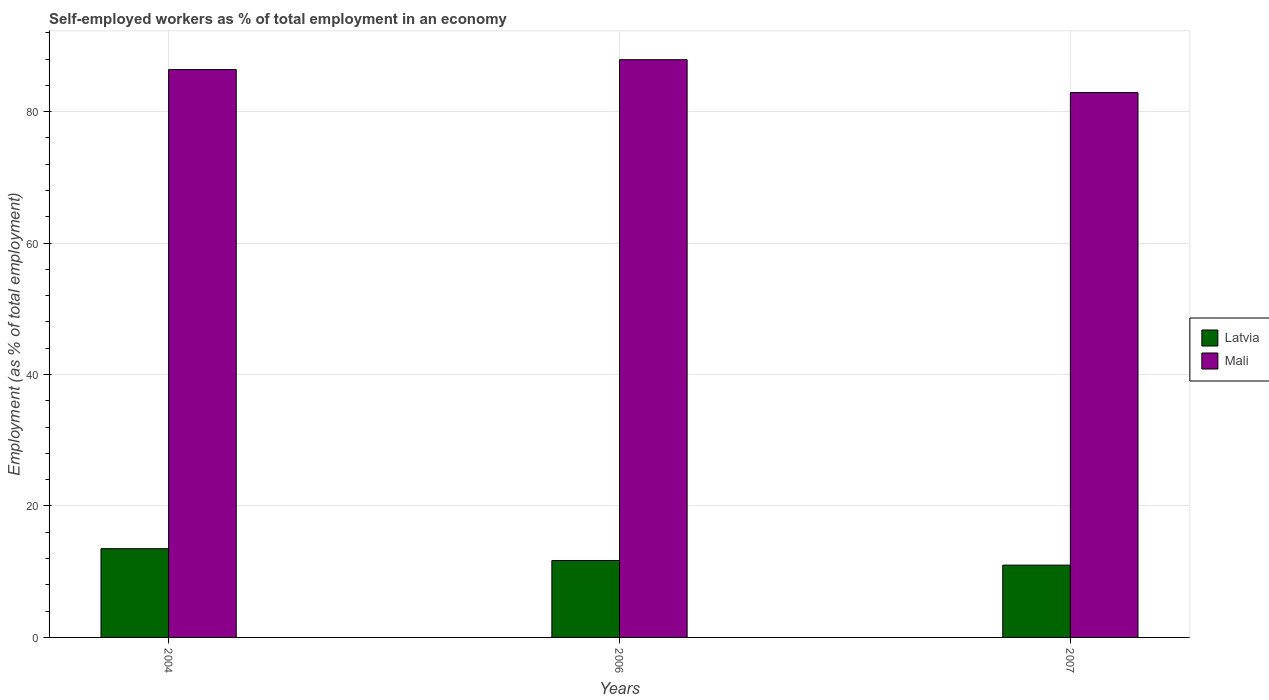How many different coloured bars are there?
Provide a succinct answer. 2. Are the number of bars per tick equal to the number of legend labels?
Your answer should be very brief. Yes. Are the number of bars on each tick of the X-axis equal?
Provide a short and direct response. Yes. How many bars are there on the 1st tick from the left?
Your answer should be very brief. 2. How many bars are there on the 1st tick from the right?
Provide a succinct answer. 2. What is the label of the 2nd group of bars from the left?
Ensure brevity in your answer.  2006. In how many cases, is the number of bars for a given year not equal to the number of legend labels?
Your response must be concise. 0. What is the percentage of self-employed workers in Latvia in 2006?
Keep it short and to the point. 11.7. Across all years, what is the maximum percentage of self-employed workers in Latvia?
Make the answer very short. 13.5. In which year was the percentage of self-employed workers in Mali minimum?
Ensure brevity in your answer.  2007. What is the total percentage of self-employed workers in Mali in the graph?
Ensure brevity in your answer.  257.2. What is the difference between the percentage of self-employed workers in Mali in 2007 and the percentage of self-employed workers in Latvia in 2006?
Provide a succinct answer. 71.2. What is the average percentage of self-employed workers in Latvia per year?
Ensure brevity in your answer.  12.07. In the year 2006, what is the difference between the percentage of self-employed workers in Latvia and percentage of self-employed workers in Mali?
Give a very brief answer. -76.2. What is the ratio of the percentage of self-employed workers in Latvia in 2004 to that in 2007?
Provide a short and direct response. 1.23. What is the difference between the highest and the second highest percentage of self-employed workers in Mali?
Your answer should be compact. 1.5. What does the 2nd bar from the left in 2004 represents?
Your answer should be compact. Mali. What does the 1st bar from the right in 2007 represents?
Offer a terse response. Mali. Are all the bars in the graph horizontal?
Provide a short and direct response. No. Does the graph contain any zero values?
Your answer should be compact. No. Where does the legend appear in the graph?
Make the answer very short. Center right. How many legend labels are there?
Ensure brevity in your answer.  2. How are the legend labels stacked?
Offer a terse response. Vertical. What is the title of the graph?
Provide a short and direct response. Self-employed workers as % of total employment in an economy. What is the label or title of the Y-axis?
Your response must be concise. Employment (as % of total employment). What is the Employment (as % of total employment) in Latvia in 2004?
Offer a terse response. 13.5. What is the Employment (as % of total employment) in Mali in 2004?
Ensure brevity in your answer.  86.4. What is the Employment (as % of total employment) of Latvia in 2006?
Keep it short and to the point. 11.7. What is the Employment (as % of total employment) of Mali in 2006?
Your answer should be very brief. 87.9. What is the Employment (as % of total employment) in Mali in 2007?
Your response must be concise. 82.9. Across all years, what is the maximum Employment (as % of total employment) of Latvia?
Your answer should be compact. 13.5. Across all years, what is the maximum Employment (as % of total employment) of Mali?
Offer a terse response. 87.9. Across all years, what is the minimum Employment (as % of total employment) of Latvia?
Your answer should be compact. 11. Across all years, what is the minimum Employment (as % of total employment) of Mali?
Your answer should be compact. 82.9. What is the total Employment (as % of total employment) of Latvia in the graph?
Make the answer very short. 36.2. What is the total Employment (as % of total employment) of Mali in the graph?
Your response must be concise. 257.2. What is the difference between the Employment (as % of total employment) of Latvia in 2004 and that in 2006?
Give a very brief answer. 1.8. What is the difference between the Employment (as % of total employment) in Mali in 2004 and that in 2006?
Provide a short and direct response. -1.5. What is the difference between the Employment (as % of total employment) of Mali in 2004 and that in 2007?
Provide a short and direct response. 3.5. What is the difference between the Employment (as % of total employment) of Latvia in 2006 and that in 2007?
Make the answer very short. 0.7. What is the difference between the Employment (as % of total employment) of Latvia in 2004 and the Employment (as % of total employment) of Mali in 2006?
Make the answer very short. -74.4. What is the difference between the Employment (as % of total employment) of Latvia in 2004 and the Employment (as % of total employment) of Mali in 2007?
Make the answer very short. -69.4. What is the difference between the Employment (as % of total employment) of Latvia in 2006 and the Employment (as % of total employment) of Mali in 2007?
Offer a terse response. -71.2. What is the average Employment (as % of total employment) of Latvia per year?
Give a very brief answer. 12.07. What is the average Employment (as % of total employment) in Mali per year?
Your answer should be very brief. 85.73. In the year 2004, what is the difference between the Employment (as % of total employment) of Latvia and Employment (as % of total employment) of Mali?
Your answer should be compact. -72.9. In the year 2006, what is the difference between the Employment (as % of total employment) of Latvia and Employment (as % of total employment) of Mali?
Your answer should be compact. -76.2. In the year 2007, what is the difference between the Employment (as % of total employment) of Latvia and Employment (as % of total employment) of Mali?
Offer a terse response. -71.9. What is the ratio of the Employment (as % of total employment) of Latvia in 2004 to that in 2006?
Provide a succinct answer. 1.15. What is the ratio of the Employment (as % of total employment) of Mali in 2004 to that in 2006?
Give a very brief answer. 0.98. What is the ratio of the Employment (as % of total employment) of Latvia in 2004 to that in 2007?
Give a very brief answer. 1.23. What is the ratio of the Employment (as % of total employment) in Mali in 2004 to that in 2007?
Give a very brief answer. 1.04. What is the ratio of the Employment (as % of total employment) in Latvia in 2006 to that in 2007?
Keep it short and to the point. 1.06. What is the ratio of the Employment (as % of total employment) in Mali in 2006 to that in 2007?
Give a very brief answer. 1.06. What is the difference between the highest and the second highest Employment (as % of total employment) of Latvia?
Your answer should be compact. 1.8. What is the difference between the highest and the lowest Employment (as % of total employment) in Mali?
Your response must be concise. 5. 